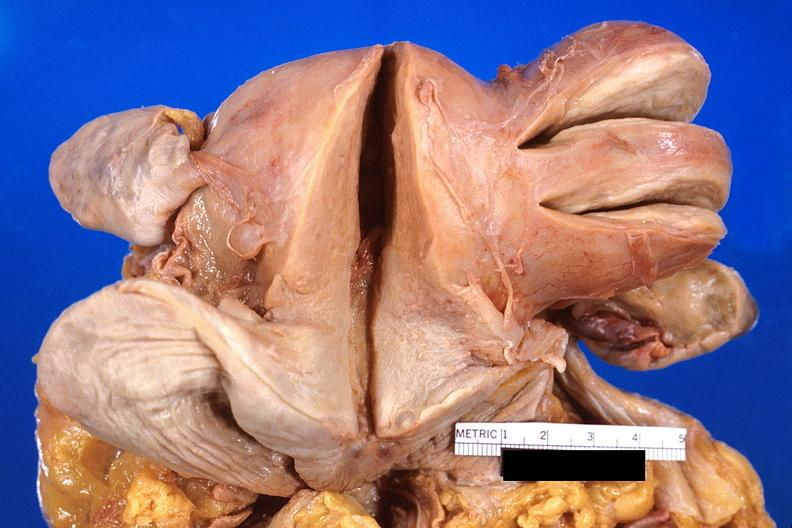what does this image show?
Answer the question using a single word or phrase. Uterus 